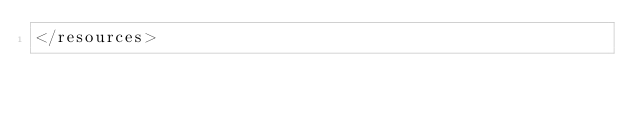Convert code to text. <code><loc_0><loc_0><loc_500><loc_500><_XML_></resources>
</code> 